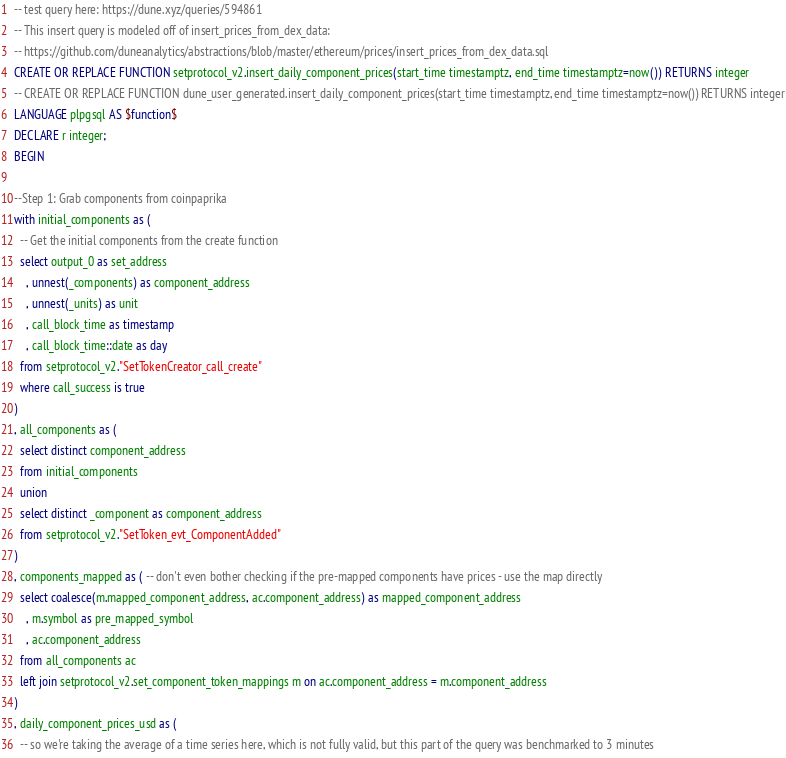Convert code to text. <code><loc_0><loc_0><loc_500><loc_500><_SQL_>-- test query here: https://dune.xyz/queries/594861
-- This insert query is modeled off of insert_prices_from_dex_data: 
-- https://github.com/duneanalytics/abstractions/blob/master/ethereum/prices/insert_prices_from_dex_data.sql
CREATE OR REPLACE FUNCTION setprotocol_v2.insert_daily_component_prices(start_time timestamptz, end_time timestamptz=now()) RETURNS integer
-- CREATE OR REPLACE FUNCTION dune_user_generated.insert_daily_component_prices(start_time timestamptz, end_time timestamptz=now()) RETURNS integer
LANGUAGE plpgsql AS $function$
DECLARE r integer;
BEGIN

--Step 1: Grab components from coinpaprika
with initial_components as (
  -- Get the initial components from the create function
  select output_0 as set_address
    , unnest(_components) as component_address
    , unnest(_units) as unit
    , call_block_time as timestamp
    , call_block_time::date as day
  from setprotocol_v2."SetTokenCreator_call_create"
  where call_success is true
)
, all_components as (
  select distinct component_address
  from initial_components
  union
  select distinct _component as component_address
  from setprotocol_v2."SetToken_evt_ComponentAdded"
)
, components_mapped as ( -- don't even bother checking if the pre-mapped components have prices - use the map directly
  select coalesce(m.mapped_component_address, ac.component_address) as mapped_component_address
    , m.symbol as pre_mapped_symbol
    , ac.component_address
  from all_components ac
  left join setprotocol_v2.set_component_token_mappings m on ac.component_address = m.component_address
)
, daily_component_prices_usd as (
  -- so we're taking the average of a time series here, which is not fully valid, but this part of the query was benchmarked to 3 minutes</code> 